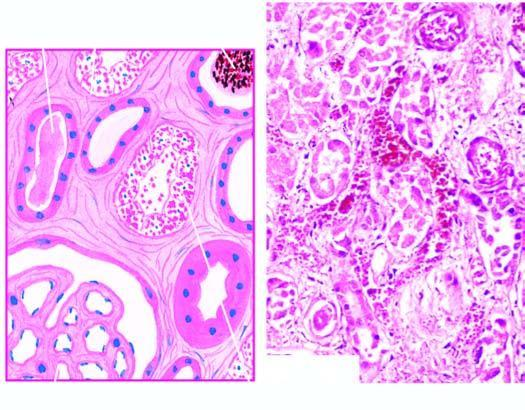do their lumina contain casts?
Answer the question using a single word or phrase. Yes 